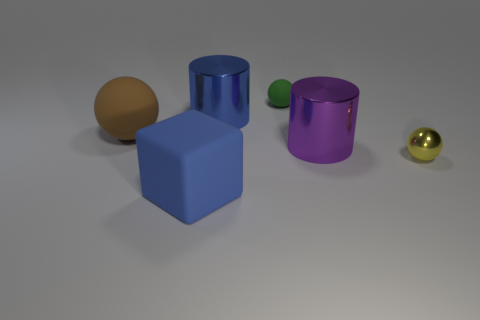Add 1 brown metallic objects. How many objects exist? 7 Subtract all cylinders. How many objects are left? 4 Subtract 0 green cylinders. How many objects are left? 6 Subtract all large purple objects. Subtract all large rubber objects. How many objects are left? 3 Add 4 brown things. How many brown things are left? 5 Add 1 big blue cubes. How many big blue cubes exist? 2 